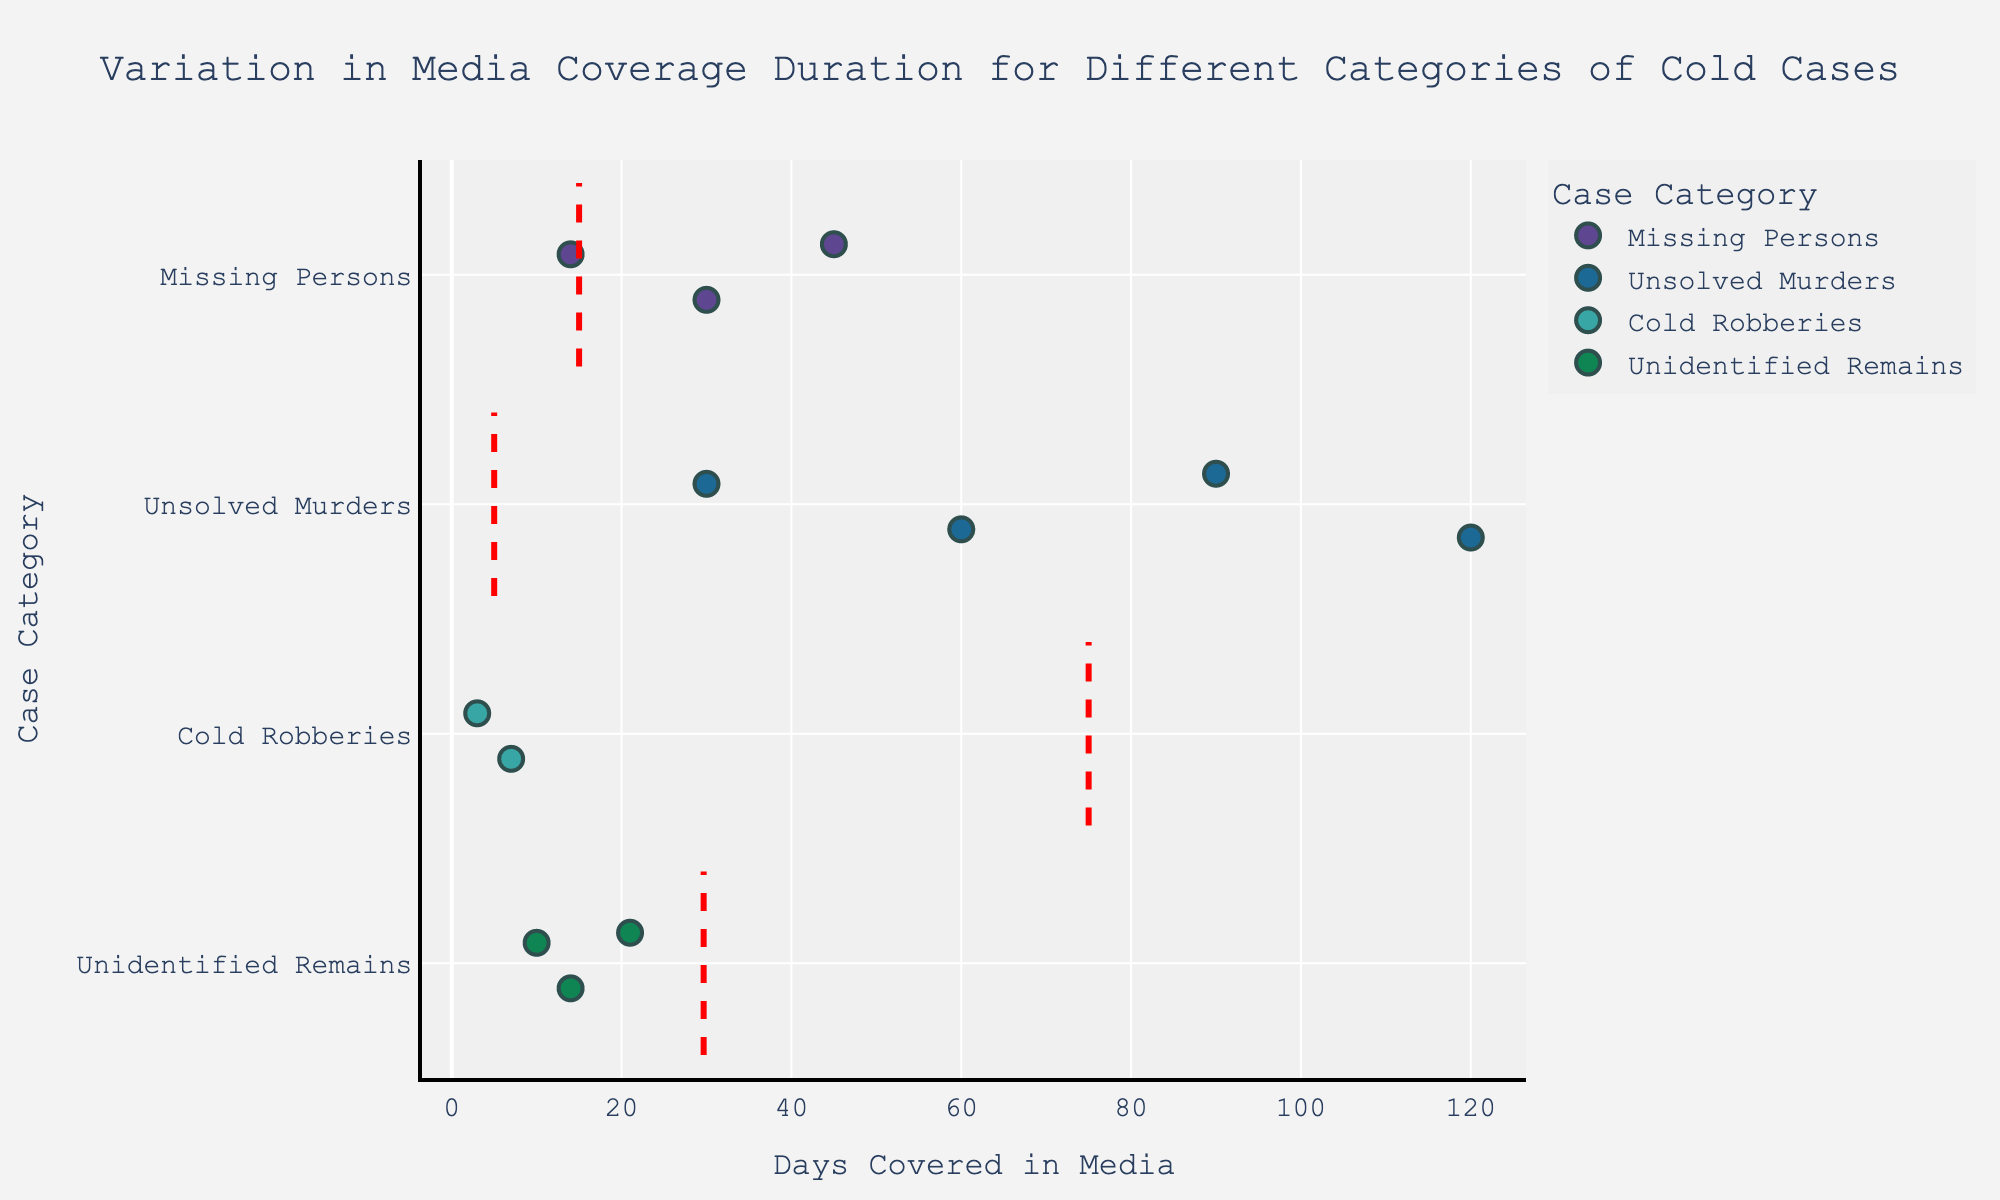What is the title of the plot? The title is displayed at the top of the plot in a larger font size, which summarizes the overall purpose of the plot.
Answer: Variation in Media Coverage Duration for Different Categories of Cold Cases Which category has the highest average number of days covered in the media? The mean line for each category indicates the average number of days covered. The category with the highest mean line represents the highest average. "Unsolved Murders" has the highest mean line.
Answer: Unsolved Murders How many cases are there in the category "Unidentified Remains"? Each point in the strip plot represents a case. The number of points for "Unidentified Remains" will give the answer.
Answer: Three Which case has the fewest days covered in the media? By examining the x-axis and identifying the point furthest to the left, we can find the case with the fewest days covered. "Dunbar Armored Robbery" is the case furthest to the left at 3 days.
Answer: Dunbar Armored Robbery Which category shows the most variation in media coverage duration? Variation can be observed by the spread or dispersion of points along the x-axis for each category. The category "Unsolved Murders" shows a wide spread from 30 to 120 days.
Answer: Unsolved Murders How many categories have a case that was covered for more than 50 days? By looking at each category and counting those with at least one point beyond 50 on the x-axis, we can find the answer. "Missing Persons" and "Unsolved Murders" have cases with more than 50 days covered.
Answer: Two What is the range of days covered in the category "Missing Persons"? The range is the difference between the maximum and minimum values. The points for "Missing Persons" range from 14 to 45 days.
Answer: 31 days Which category has the least average number of days covered in the media? The mean line for each category indicates the average number of days covered. The category with the lowest mean line represents the lowest average. "Cold Robberies" has the lowest mean line.
Answer: Cold Robberies Is there a category where all cases received less than 50 days of media coverage? By checking the x-axis and seeing if any points in a category lie to the right of 50, we find that "Cold Robberies" has no points beyond 50.
Answer: Cold Robberies 